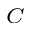<formula> <loc_0><loc_0><loc_500><loc_500>_ { C }</formula> 